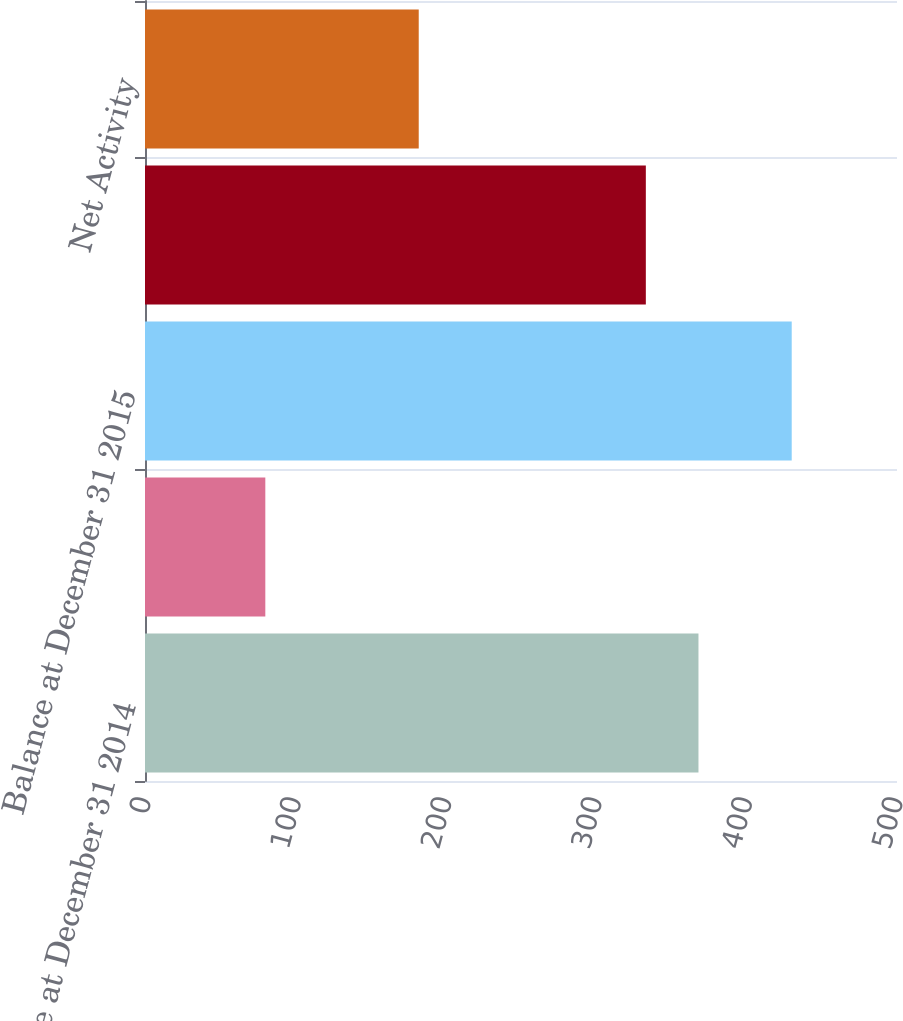Convert chart. <chart><loc_0><loc_0><loc_500><loc_500><bar_chart><fcel>Balance at December 31 2014<fcel>Net activity<fcel>Balance at December 31 2015<fcel>Balance at December 31 2016<fcel>Net Activity<nl><fcel>368<fcel>80<fcel>430<fcel>333<fcel>182<nl></chart> 